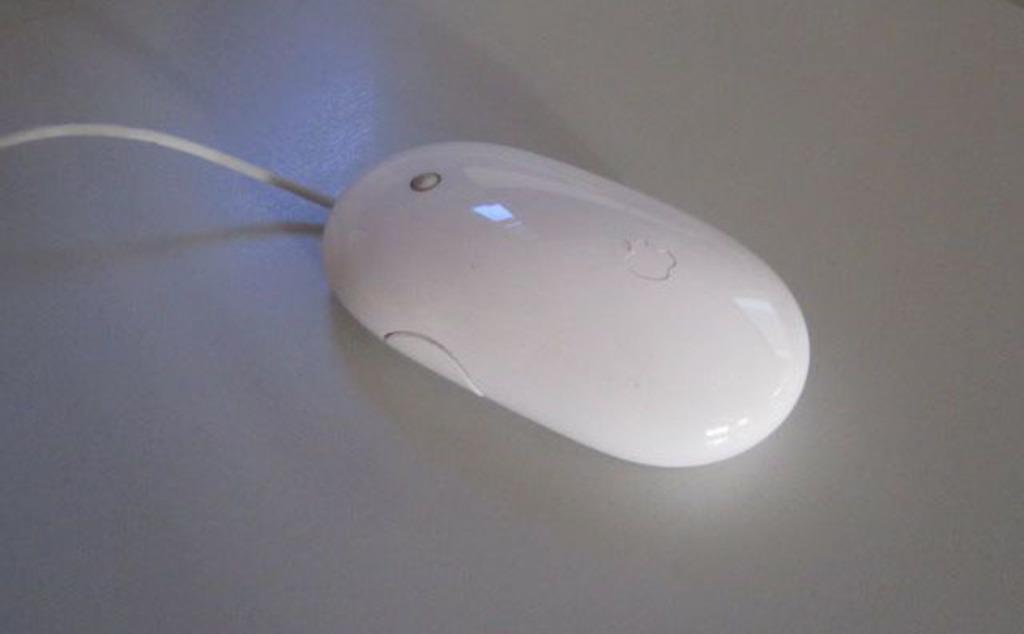Describe this image in one or two sentences. It is a mouse which is in white color. 